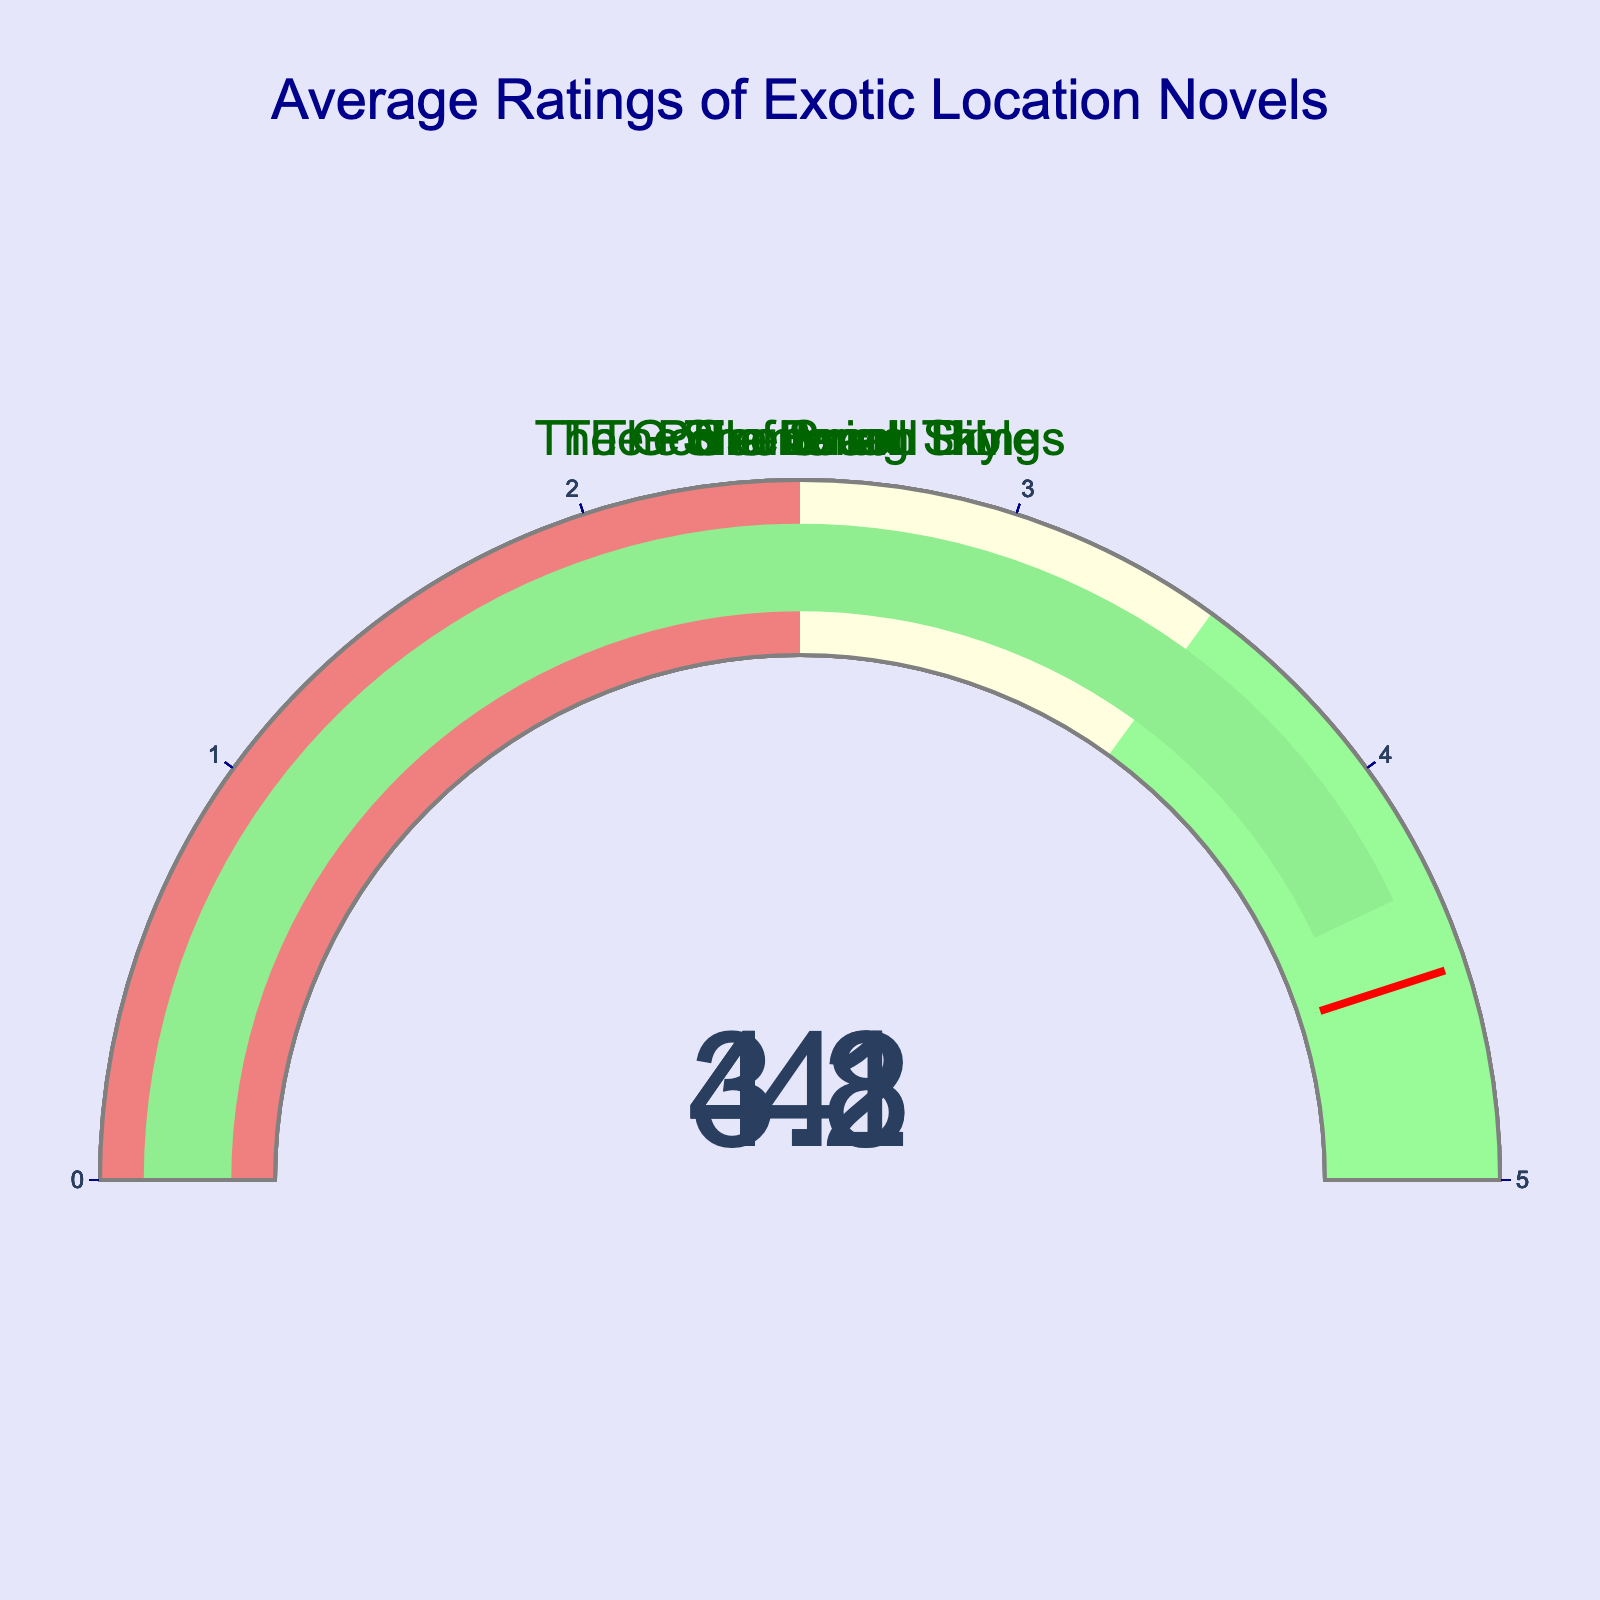What's the title of the book with the highest average rating? Look at the gauge displaying the highest value among the gauges. The book with the highest rating will have its title displayed above it.
Answer: "Shantaram" What's the average rating of "The Beach"? Locate the gauge with the title "The Beach." The average rating is indicated by the number inside the gauge.
Answer: 3.8 Which book has a higher rating: "The God of Small Things" or "The Sheltering Sky"? Compare the gauges for "The God of Small Things" and "The Sheltering Sky". Check the numbers inside each gauge.
Answer: "The God of Small Things" What's the combined average rating of "The Poisonwood Bible" and "Shantaram"? Find the gauges for "The Poisonwood Bible" and "Shantaram". Add their average ratings together: 4.2 + 4.3.
Answer: 8.5 Which book's rating is closest to 4.0? Look at all gauges and find the rating closest to 4.0. Compare the proximity of each rating to 4.0.
Answer: "The Sheltering Sky" How many books have an average rating above 4.0? Count the number of gauges with values greater than 4.0.
Answer: 3 Is there any book with an average rating lower than 4.0? Examine each gauge to see if any of the values are below 4.0.
Answer: Yes What is the average rating of all the books combined? Sum all the ratings: 4.1 + 3.8 + 4.0 + 4.2 + 4.3 and divide by the number of books, 5. The calculation: (4.1 + 3.8 + 4.0 + 4.2 + 4.3) / 5 = 4.08
Answer: 4.08 